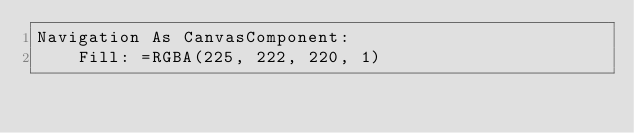Convert code to text. <code><loc_0><loc_0><loc_500><loc_500><_YAML_>Navigation As CanvasComponent:
    Fill: =RGBA(225, 222, 220, 1)</code> 